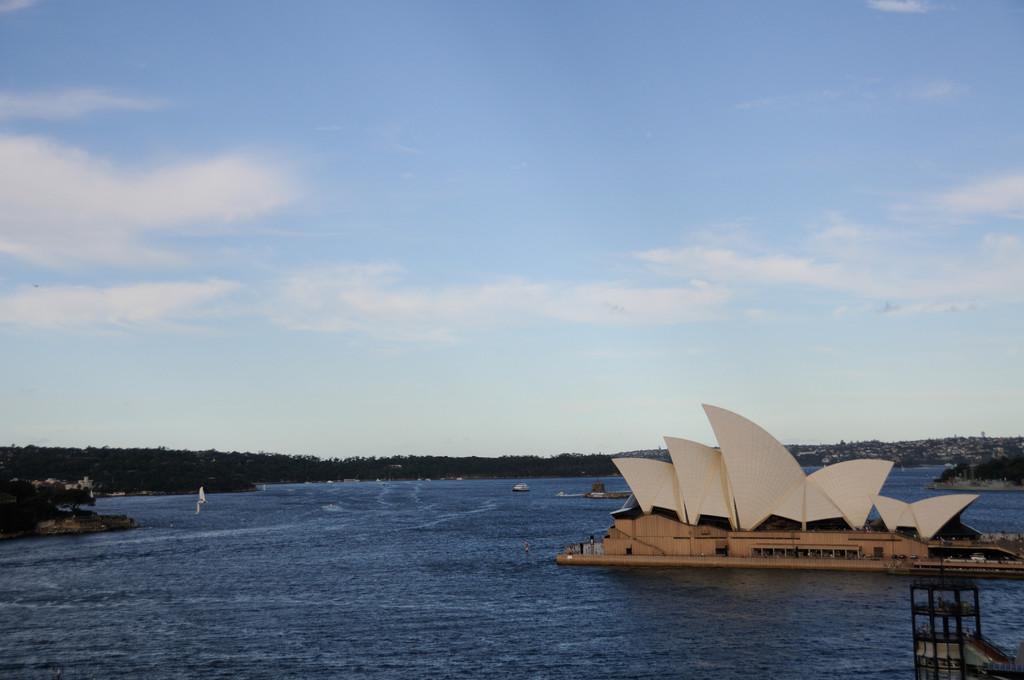How would you summarize this image in a sentence or two? In this image we can see an opera house. We can also see a lake, trees and the sky which looks cloudy. 